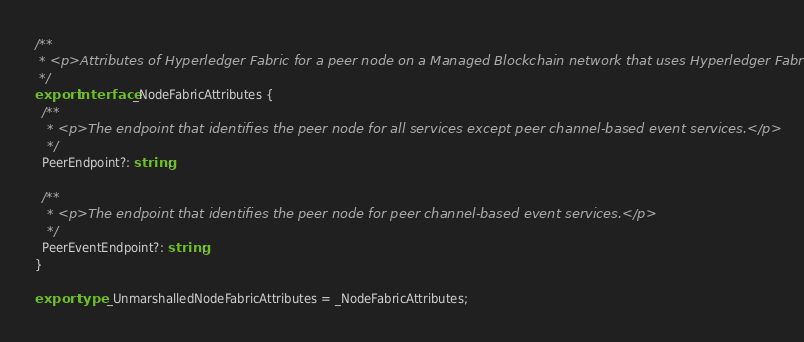<code> <loc_0><loc_0><loc_500><loc_500><_TypeScript_>/**
 * <p>Attributes of Hyperledger Fabric for a peer node on a Managed Blockchain network that uses Hyperledger Fabric.</p>
 */
export interface _NodeFabricAttributes {
  /**
   * <p>The endpoint that identifies the peer node for all services except peer channel-based event services.</p>
   */
  PeerEndpoint?: string;

  /**
   * <p>The endpoint that identifies the peer node for peer channel-based event services.</p>
   */
  PeerEventEndpoint?: string;
}

export type _UnmarshalledNodeFabricAttributes = _NodeFabricAttributes;
</code> 